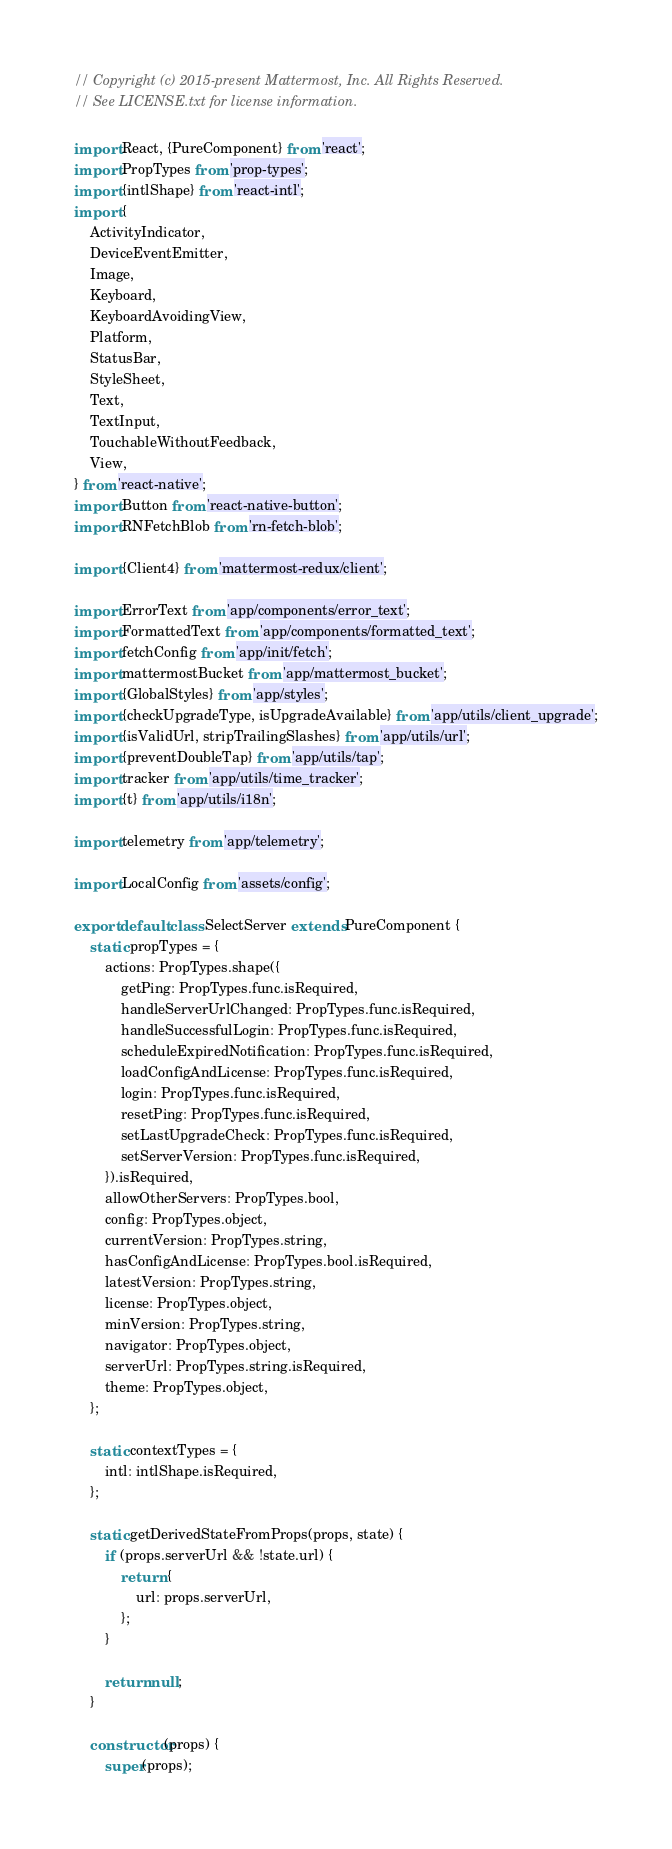Convert code to text. <code><loc_0><loc_0><loc_500><loc_500><_JavaScript_>// Copyright (c) 2015-present Mattermost, Inc. All Rights Reserved.
// See LICENSE.txt for license information.

import React, {PureComponent} from 'react';
import PropTypes from 'prop-types';
import {intlShape} from 'react-intl';
import {
    ActivityIndicator,
    DeviceEventEmitter,
    Image,
    Keyboard,
    KeyboardAvoidingView,
    Platform,
    StatusBar,
    StyleSheet,
    Text,
    TextInput,
    TouchableWithoutFeedback,
    View,
} from 'react-native';
import Button from 'react-native-button';
import RNFetchBlob from 'rn-fetch-blob';

import {Client4} from 'mattermost-redux/client';

import ErrorText from 'app/components/error_text';
import FormattedText from 'app/components/formatted_text';
import fetchConfig from 'app/init/fetch';
import mattermostBucket from 'app/mattermost_bucket';
import {GlobalStyles} from 'app/styles';
import {checkUpgradeType, isUpgradeAvailable} from 'app/utils/client_upgrade';
import {isValidUrl, stripTrailingSlashes} from 'app/utils/url';
import {preventDoubleTap} from 'app/utils/tap';
import tracker from 'app/utils/time_tracker';
import {t} from 'app/utils/i18n';

import telemetry from 'app/telemetry';

import LocalConfig from 'assets/config';

export default class SelectServer extends PureComponent {
    static propTypes = {
        actions: PropTypes.shape({
            getPing: PropTypes.func.isRequired,
            handleServerUrlChanged: PropTypes.func.isRequired,
            handleSuccessfulLogin: PropTypes.func.isRequired,
            scheduleExpiredNotification: PropTypes.func.isRequired,
            loadConfigAndLicense: PropTypes.func.isRequired,
            login: PropTypes.func.isRequired,
            resetPing: PropTypes.func.isRequired,
            setLastUpgradeCheck: PropTypes.func.isRequired,
            setServerVersion: PropTypes.func.isRequired,
        }).isRequired,
        allowOtherServers: PropTypes.bool,
        config: PropTypes.object,
        currentVersion: PropTypes.string,
        hasConfigAndLicense: PropTypes.bool.isRequired,
        latestVersion: PropTypes.string,
        license: PropTypes.object,
        minVersion: PropTypes.string,
        navigator: PropTypes.object,
        serverUrl: PropTypes.string.isRequired,
        theme: PropTypes.object,
    };

    static contextTypes = {
        intl: intlShape.isRequired,
    };

    static getDerivedStateFromProps(props, state) {
        if (props.serverUrl && !state.url) {
            return {
                url: props.serverUrl,
            };
        }

        return null;
    }

    constructor(props) {
        super(props);
</code> 